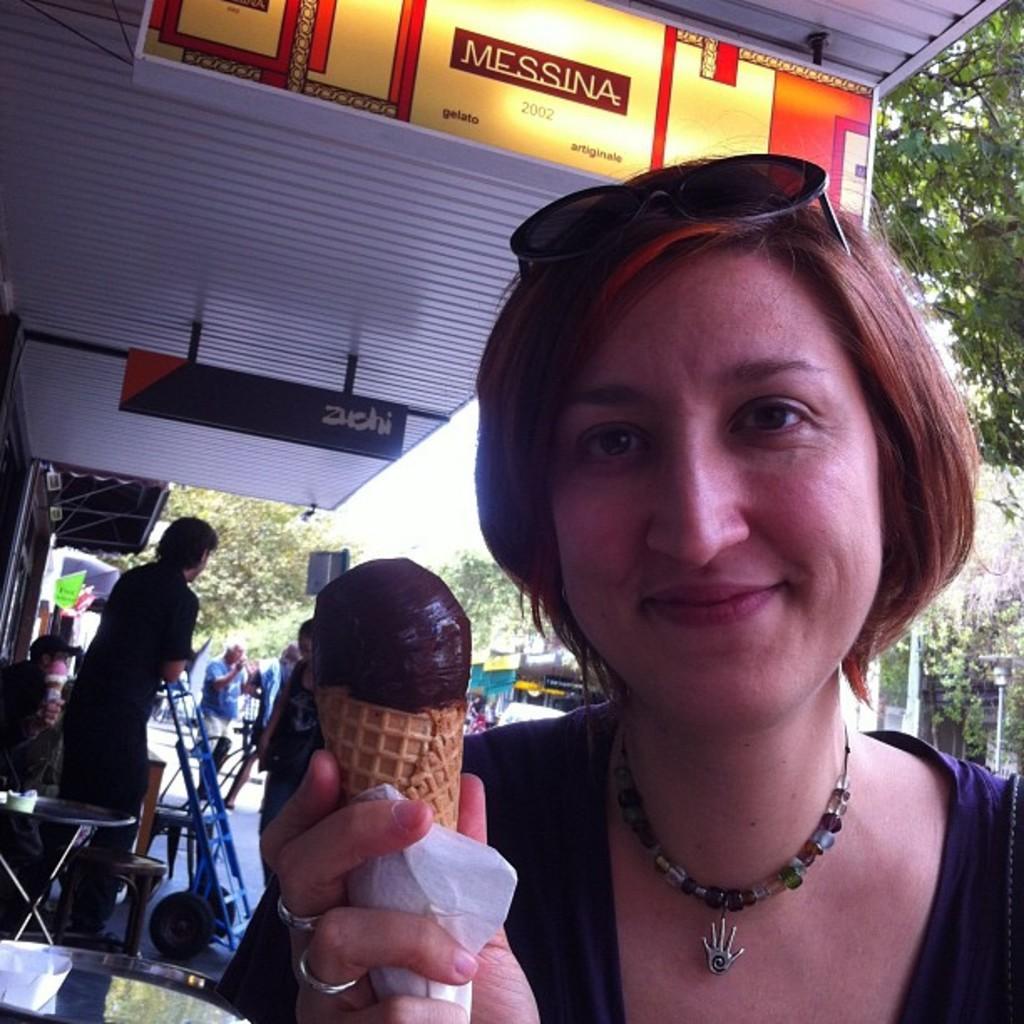Can you describe this image briefly? In this picture we can see a woman holding a ice cream cone and a tissue paper with her hand and smiling and in the background we can see some persons standing, tables, chairs, trees. 